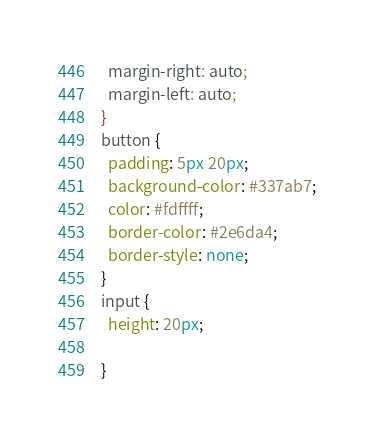<code> <loc_0><loc_0><loc_500><loc_500><_CSS_>  margin-right: auto;
  margin-left: auto;
}
button {
  padding: 5px 20px;
  background-color: #337ab7;
  color: #fdffff;
  border-color: #2e6da4;
  border-style: none;
}
input {
  height: 20px;
  
}
</code> 